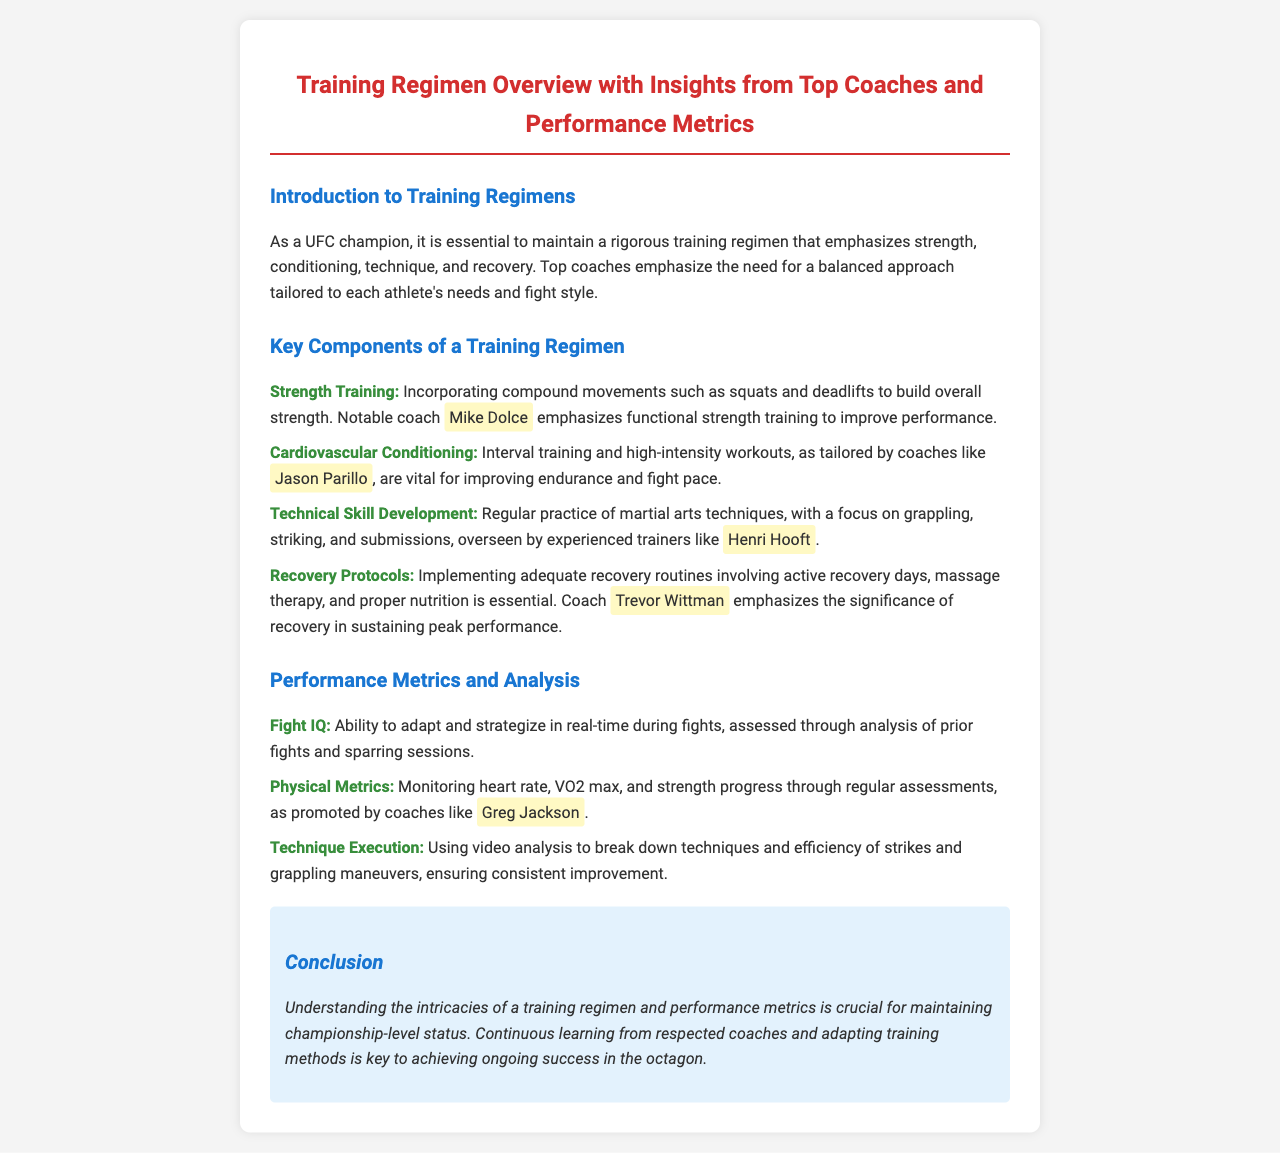What is emphasized in the introduction about training regimens? The introduction highlights the need for a balanced approach tailored to each athlete's needs and fight style.
Answer: Balanced approach Who emphasizes functional strength training? The document names Mike Dolce as the coach who emphasizes functional strength training for performance improvement.
Answer: Mike Dolce What type of training is key for improving endurance according to Jason Parillo? The document states that interval training and high-intensity workouts are vital for improving endurance and fight pace.
Answer: Interval training What performance metric involves adapting and strategizing in real-time? The document refers to "Fight IQ" as the metric assessed through analysis of fights and sparring sessions.
Answer: Fight IQ Which coach highlights the importance of recovery protocols? Trevor Wittman is mentioned as the coach who emphasizes the significance of recovery in sustaining peak performance.
Answer: Trevor Wittman What analysis method is used for technique execution evaluation? Video analysis is used to break down techniques and the efficiency of strikes and grappling maneuvers.
Answer: Video analysis How does Greg Jackson promote physical metrics monitoring? Greg Jackson promotes monitoring through regular assessments of heart rate, VO2 max, and strength progress.
Answer: Regular assessments What is the conclusion about understanding training regimens and performance metrics? The conclusion states that understanding them is crucial for maintaining championship-level status.
Answer: Crucial for maintaining championship-level status 